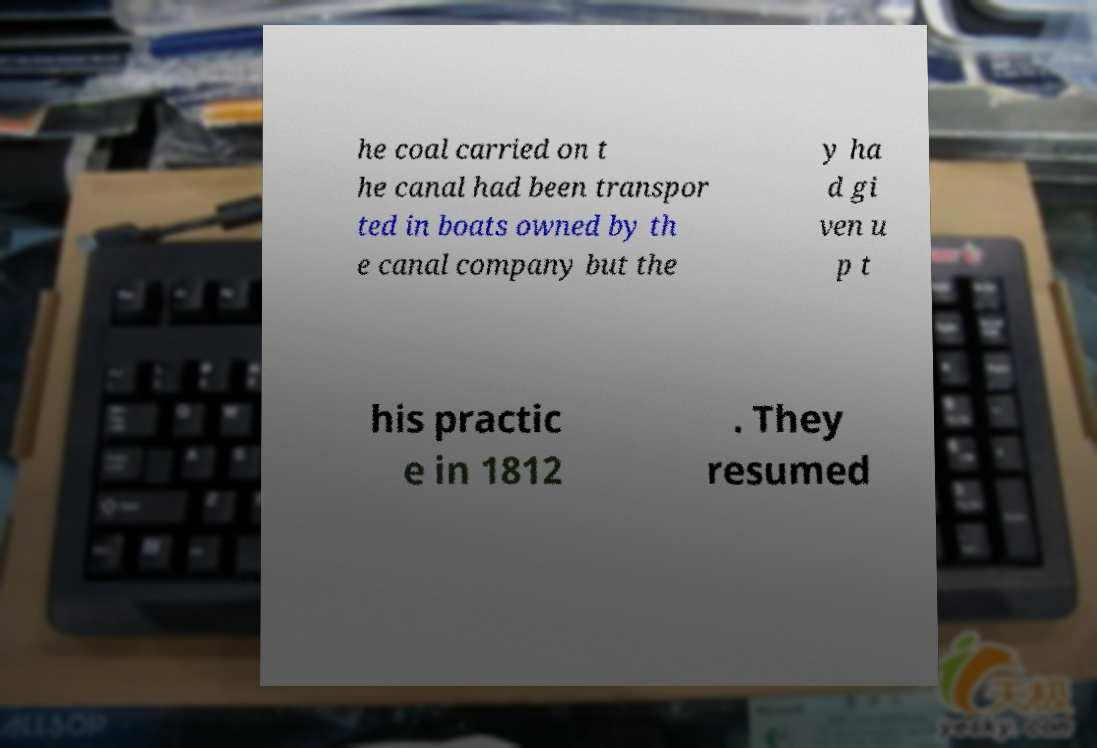I need the written content from this picture converted into text. Can you do that? he coal carried on t he canal had been transpor ted in boats owned by th e canal company but the y ha d gi ven u p t his practic e in 1812 . They resumed 